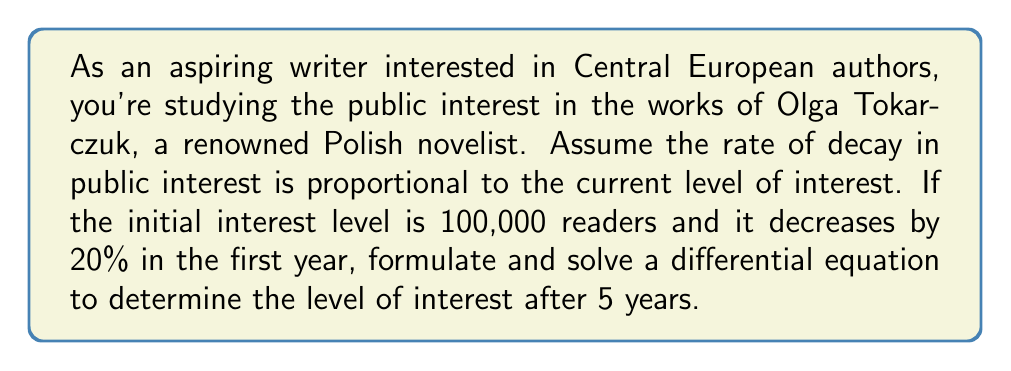Can you answer this question? Let's approach this step-by-step:

1) Let $I(t)$ be the level of interest at time $t$ (in years).

2) The rate of change of interest is proportional to the current interest level:

   $$\frac{dI}{dt} = -kI$$

   where $k$ is the decay constant.

3) We're given that $I(0) = 100,000$ (initial condition).

4) After one year, the interest has decreased by 20%, so $I(1) = 80,000$.

5) We can use this to find $k$:

   $$I(t) = I(0)e^{-kt}$$
   $$80,000 = 100,000e^{-k(1)}$$
   $$0.8 = e^{-k}$$
   $$\ln(0.8) = -k$$
   $$k = -\ln(0.8) \approx 0.2231$$

6) Now we have our complete differential equation:

   $$\frac{dI}{dt} = -0.2231I, \quad I(0) = 100,000$$

7) The solution to this equation is:

   $$I(t) = 100,000e^{-0.2231t}$$

8) To find the interest level after 5 years, we evaluate $I(5)$:

   $$I(5) = 100,000e^{-0.2231(5)} \approx 32,768$$

Therefore, after 5 years, the level of interest will be approximately 32,768 readers.
Answer: $I(5) \approx 32,768$ readers 